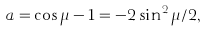Convert formula to latex. <formula><loc_0><loc_0><loc_500><loc_500>a = \cos \mu - 1 = - 2 \sin ^ { 2 } \mu / 2 ,</formula> 